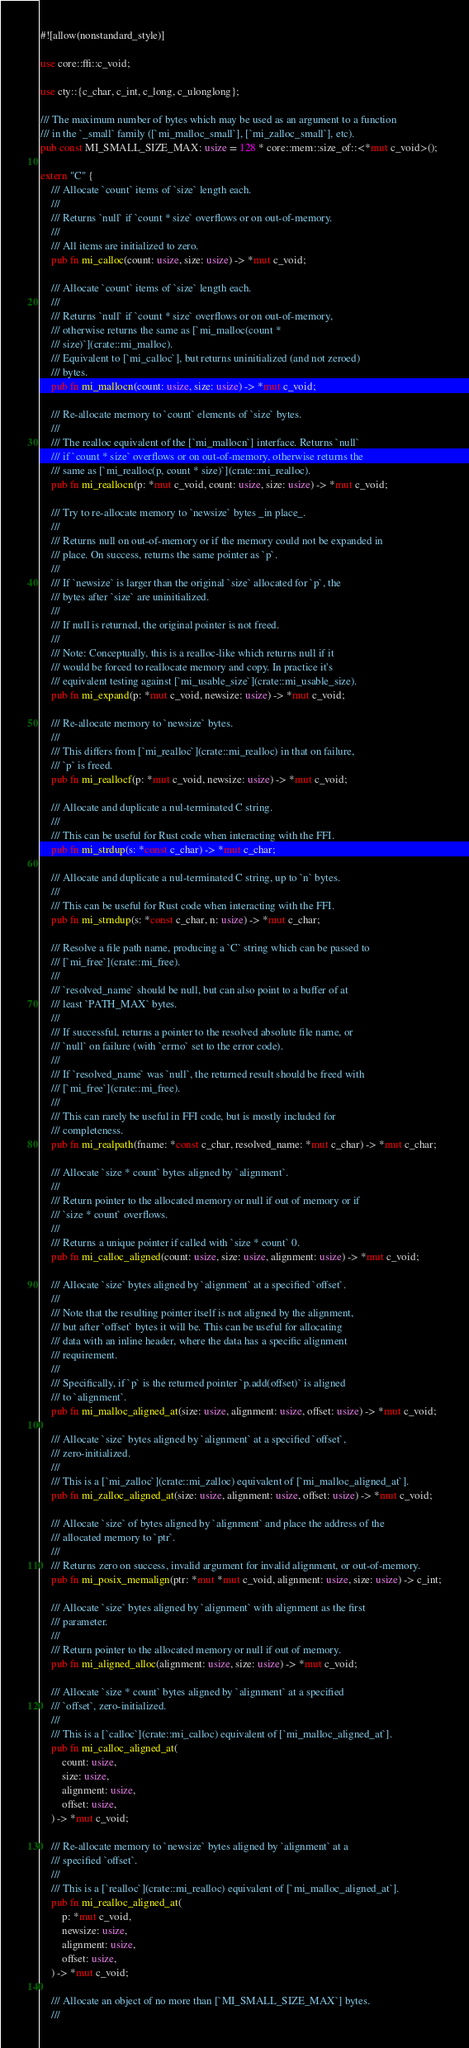<code> <loc_0><loc_0><loc_500><loc_500><_Rust_>#![allow(nonstandard_style)]

use core::ffi::c_void;

use cty::{c_char, c_int, c_long, c_ulonglong};

/// The maximum number of bytes which may be used as an argument to a function
/// in the `_small` family ([`mi_malloc_small`], [`mi_zalloc_small`], etc).
pub const MI_SMALL_SIZE_MAX: usize = 128 * core::mem::size_of::<*mut c_void>();

extern "C" {
    /// Allocate `count` items of `size` length each.
    ///
    /// Returns `null` if `count * size` overflows or on out-of-memory.
    ///
    /// All items are initialized to zero.
    pub fn mi_calloc(count: usize, size: usize) -> *mut c_void;

    /// Allocate `count` items of `size` length each.
    ///
    /// Returns `null` if `count * size` overflows or on out-of-memory,
    /// otherwise returns the same as [`mi_malloc(count *
    /// size)`](crate::mi_malloc).
    /// Equivalent to [`mi_calloc`], but returns uninitialized (and not zeroed)
    /// bytes.
    pub fn mi_mallocn(count: usize, size: usize) -> *mut c_void;

    /// Re-allocate memory to `count` elements of `size` bytes.
    ///
    /// The realloc equivalent of the [`mi_mallocn`] interface. Returns `null`
    /// if `count * size` overflows or on out-of-memory, otherwise returns the
    /// same as [`mi_realloc(p, count * size)`](crate::mi_realloc).
    pub fn mi_reallocn(p: *mut c_void, count: usize, size: usize) -> *mut c_void;

    /// Try to re-allocate memory to `newsize` bytes _in place_.
    ///
    /// Returns null on out-of-memory or if the memory could not be expanded in
    /// place. On success, returns the same pointer as `p`.
    ///
    /// If `newsize` is larger than the original `size` allocated for `p`, the
    /// bytes after `size` are uninitialized.
    ///
    /// If null is returned, the original pointer is not freed.
    ///
    /// Note: Conceptually, this is a realloc-like which returns null if it
    /// would be forced to reallocate memory and copy. In practice it's
    /// equivalent testing against [`mi_usable_size`](crate::mi_usable_size).
    pub fn mi_expand(p: *mut c_void, newsize: usize) -> *mut c_void;

    /// Re-allocate memory to `newsize` bytes.
    ///
    /// This differs from [`mi_realloc`](crate::mi_realloc) in that on failure,
    /// `p` is freed.
    pub fn mi_reallocf(p: *mut c_void, newsize: usize) -> *mut c_void;

    /// Allocate and duplicate a nul-terminated C string.
    ///
    /// This can be useful for Rust code when interacting with the FFI.
    pub fn mi_strdup(s: *const c_char) -> *mut c_char;

    /// Allocate and duplicate a nul-terminated C string, up to `n` bytes.
    ///
    /// This can be useful for Rust code when interacting with the FFI.
    pub fn mi_strndup(s: *const c_char, n: usize) -> *mut c_char;

    /// Resolve a file path name, producing a `C` string which can be passed to
    /// [`mi_free`](crate::mi_free).
    ///
    /// `resolved_name` should be null, but can also point to a buffer of at
    /// least `PATH_MAX` bytes.
    ///
    /// If successful, returns a pointer to the resolved absolute file name, or
    /// `null` on failure (with `errno` set to the error code).
    ///
    /// If `resolved_name` was `null`, the returned result should be freed with
    /// [`mi_free`](crate::mi_free).
    ///
    /// This can rarely be useful in FFI code, but is mostly included for
    /// completeness.
    pub fn mi_realpath(fname: *const c_char, resolved_name: *mut c_char) -> *mut c_char;

    /// Allocate `size * count` bytes aligned by `alignment`.
    ///
    /// Return pointer to the allocated memory or null if out of memory or if
    /// `size * count` overflows.
    ///
    /// Returns a unique pointer if called with `size * count` 0.
    pub fn mi_calloc_aligned(count: usize, size: usize, alignment: usize) -> *mut c_void;

    /// Allocate `size` bytes aligned by `alignment` at a specified `offset`.
    ///
    /// Note that the resulting pointer itself is not aligned by the alignment,
    /// but after `offset` bytes it will be. This can be useful for allocating
    /// data with an inline header, where the data has a specific alignment
    /// requirement.
    ///
    /// Specifically, if `p` is the returned pointer `p.add(offset)` is aligned
    /// to `alignment`.
    pub fn mi_malloc_aligned_at(size: usize, alignment: usize, offset: usize) -> *mut c_void;

    /// Allocate `size` bytes aligned by `alignment` at a specified `offset`,
    /// zero-initialized.
    ///
    /// This is a [`mi_zalloc`](crate::mi_zalloc) equivalent of [`mi_malloc_aligned_at`].
    pub fn mi_zalloc_aligned_at(size: usize, alignment: usize, offset: usize) -> *mut c_void;

    /// Allocate `size` of bytes aligned by `alignment` and place the address of the
    /// allocated memory to `ptr`.
    ///
    /// Returns zero on success, invalid argument for invalid alignment, or out-of-memory.
    pub fn mi_posix_memalign(ptr: *mut *mut c_void, alignment: usize, size: usize) -> c_int;

    /// Allocate `size` bytes aligned by `alignment` with alignment as the first
    /// parameter.
    ///
    /// Return pointer to the allocated memory or null if out of memory.
    pub fn mi_aligned_alloc(alignment: usize, size: usize) -> *mut c_void;

    /// Allocate `size * count` bytes aligned by `alignment` at a specified
    /// `offset`, zero-initialized.
    ///
    /// This is a [`calloc`](crate::mi_calloc) equivalent of [`mi_malloc_aligned_at`].
    pub fn mi_calloc_aligned_at(
        count: usize,
        size: usize,
        alignment: usize,
        offset: usize,
    ) -> *mut c_void;

    /// Re-allocate memory to `newsize` bytes aligned by `alignment` at a
    /// specified `offset`.
    ///
    /// This is a [`realloc`](crate::mi_realloc) equivalent of [`mi_malloc_aligned_at`].
    pub fn mi_realloc_aligned_at(
        p: *mut c_void,
        newsize: usize,
        alignment: usize,
        offset: usize,
    ) -> *mut c_void;

    /// Allocate an object of no more than [`MI_SMALL_SIZE_MAX`] bytes.
    ///</code> 